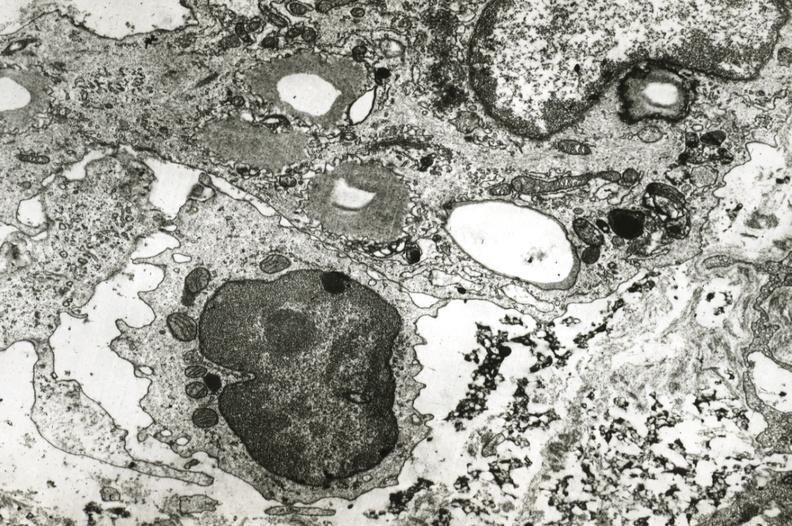what does this image show?
Answer the question using a single word or phrase. Smooth muscle cell with lipid monocyte and precipitated lipid in interstitial space 